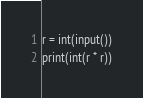Convert code to text. <code><loc_0><loc_0><loc_500><loc_500><_Python_>r = int(input())
print(int(r * r))</code> 